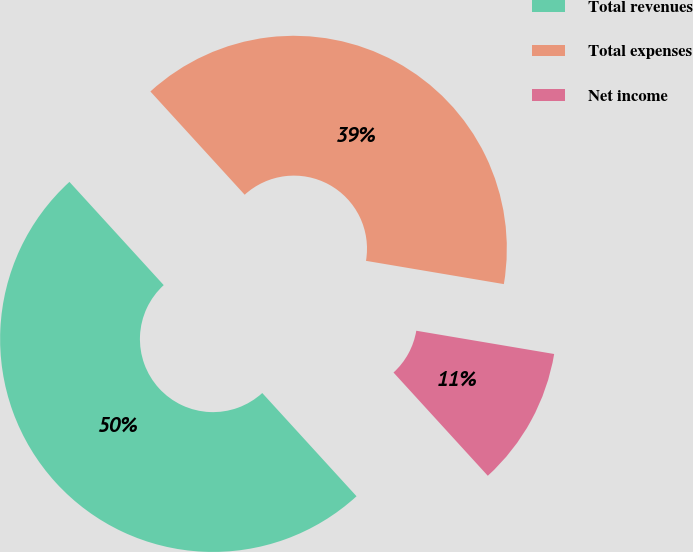Convert chart. <chart><loc_0><loc_0><loc_500><loc_500><pie_chart><fcel>Total revenues<fcel>Total expenses<fcel>Net income<nl><fcel>50.0%<fcel>39.44%<fcel>10.56%<nl></chart> 